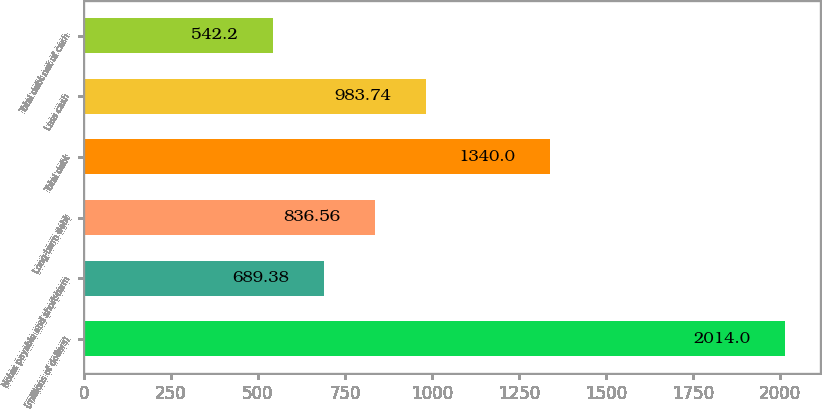Convert chart. <chart><loc_0><loc_0><loc_500><loc_500><bar_chart><fcel>(millions of dollars)<fcel>Notes payable and short-term<fcel>Long-term debt<fcel>Total debt<fcel>Less cash<fcel>Total debt net of cash<nl><fcel>2014<fcel>689.38<fcel>836.56<fcel>1340<fcel>983.74<fcel>542.2<nl></chart> 